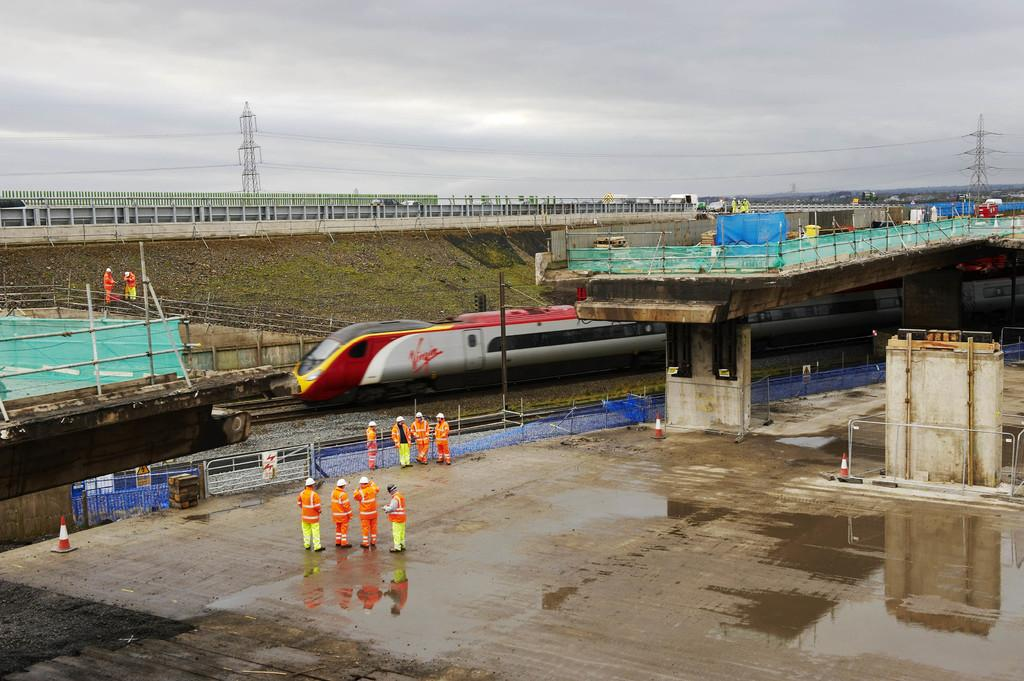<image>
Write a terse but informative summary of the picture. A Virgin brand train is outside on the track. 